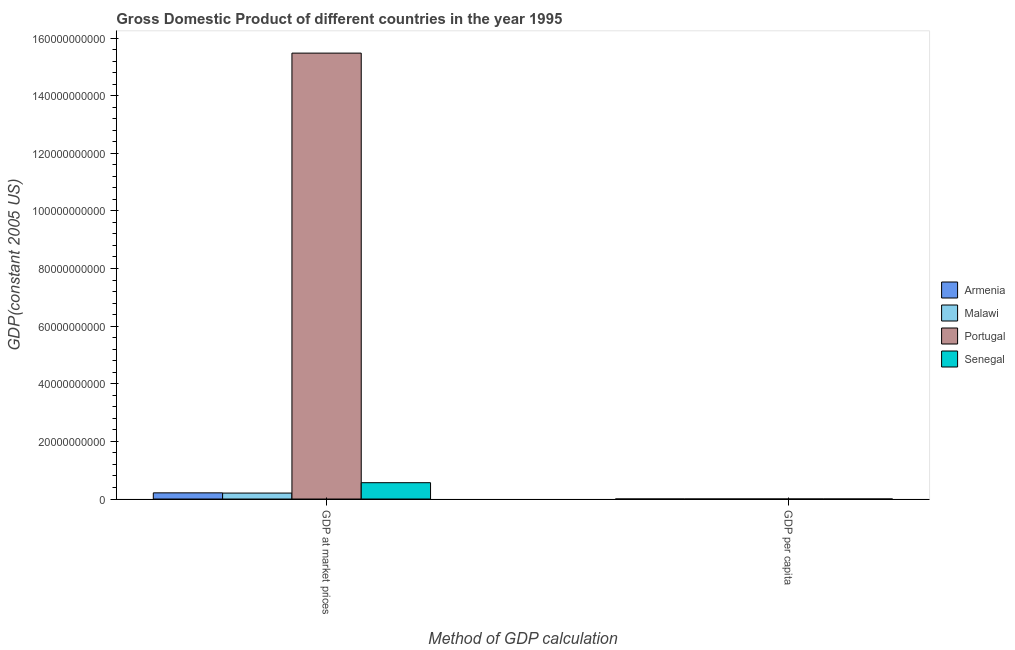How many different coloured bars are there?
Ensure brevity in your answer.  4. How many groups of bars are there?
Provide a succinct answer. 2. Are the number of bars per tick equal to the number of legend labels?
Keep it short and to the point. Yes. Are the number of bars on each tick of the X-axis equal?
Make the answer very short. Yes. How many bars are there on the 1st tick from the left?
Provide a succinct answer. 4. How many bars are there on the 2nd tick from the right?
Keep it short and to the point. 4. What is the label of the 1st group of bars from the left?
Keep it short and to the point. GDP at market prices. What is the gdp per capita in Armenia?
Your response must be concise. 665.72. Across all countries, what is the maximum gdp at market prices?
Provide a short and direct response. 1.55e+11. Across all countries, what is the minimum gdp per capita?
Your answer should be very brief. 210.62. In which country was the gdp at market prices minimum?
Your response must be concise. Malawi. What is the total gdp per capita in the graph?
Provide a succinct answer. 1.70e+04. What is the difference between the gdp at market prices in Armenia and that in Malawi?
Offer a terse response. 7.68e+07. What is the difference between the gdp at market prices in Portugal and the gdp per capita in Armenia?
Keep it short and to the point. 1.55e+11. What is the average gdp per capita per country?
Provide a short and direct response. 4240.57. What is the difference between the gdp per capita and gdp at market prices in Armenia?
Offer a very short reply. -2.15e+09. What is the ratio of the gdp per capita in Armenia to that in Portugal?
Provide a succinct answer. 0.04. Is the gdp per capita in Armenia less than that in Malawi?
Offer a terse response. No. What does the 3rd bar from the left in GDP at market prices represents?
Keep it short and to the point. Portugal. What does the 4th bar from the right in GDP at market prices represents?
Provide a short and direct response. Armenia. What is the difference between two consecutive major ticks on the Y-axis?
Your answer should be very brief. 2.00e+1. Are the values on the major ticks of Y-axis written in scientific E-notation?
Keep it short and to the point. No. Where does the legend appear in the graph?
Ensure brevity in your answer.  Center right. How many legend labels are there?
Your answer should be very brief. 4. What is the title of the graph?
Your answer should be compact. Gross Domestic Product of different countries in the year 1995. What is the label or title of the X-axis?
Provide a short and direct response. Method of GDP calculation. What is the label or title of the Y-axis?
Offer a very short reply. GDP(constant 2005 US). What is the GDP(constant 2005 US) of Armenia in GDP at market prices?
Make the answer very short. 2.15e+09. What is the GDP(constant 2005 US) of Malawi in GDP at market prices?
Make the answer very short. 2.07e+09. What is the GDP(constant 2005 US) in Portugal in GDP at market prices?
Ensure brevity in your answer.  1.55e+11. What is the GDP(constant 2005 US) in Senegal in GDP at market prices?
Offer a terse response. 5.67e+09. What is the GDP(constant 2005 US) of Armenia in GDP per capita?
Make the answer very short. 665.72. What is the GDP(constant 2005 US) in Malawi in GDP per capita?
Your answer should be very brief. 210.62. What is the GDP(constant 2005 US) of Portugal in GDP per capita?
Provide a short and direct response. 1.54e+04. What is the GDP(constant 2005 US) in Senegal in GDP per capita?
Offer a terse response. 651.02. Across all Method of GDP calculation, what is the maximum GDP(constant 2005 US) of Armenia?
Give a very brief answer. 2.15e+09. Across all Method of GDP calculation, what is the maximum GDP(constant 2005 US) in Malawi?
Keep it short and to the point. 2.07e+09. Across all Method of GDP calculation, what is the maximum GDP(constant 2005 US) in Portugal?
Your answer should be very brief. 1.55e+11. Across all Method of GDP calculation, what is the maximum GDP(constant 2005 US) of Senegal?
Offer a terse response. 5.67e+09. Across all Method of GDP calculation, what is the minimum GDP(constant 2005 US) in Armenia?
Your answer should be compact. 665.72. Across all Method of GDP calculation, what is the minimum GDP(constant 2005 US) of Malawi?
Give a very brief answer. 210.62. Across all Method of GDP calculation, what is the minimum GDP(constant 2005 US) in Portugal?
Give a very brief answer. 1.54e+04. Across all Method of GDP calculation, what is the minimum GDP(constant 2005 US) of Senegal?
Provide a succinct answer. 651.02. What is the total GDP(constant 2005 US) of Armenia in the graph?
Ensure brevity in your answer.  2.15e+09. What is the total GDP(constant 2005 US) of Malawi in the graph?
Keep it short and to the point. 2.07e+09. What is the total GDP(constant 2005 US) of Portugal in the graph?
Your answer should be compact. 1.55e+11. What is the total GDP(constant 2005 US) in Senegal in the graph?
Provide a succinct answer. 5.67e+09. What is the difference between the GDP(constant 2005 US) of Armenia in GDP at market prices and that in GDP per capita?
Provide a short and direct response. 2.15e+09. What is the difference between the GDP(constant 2005 US) of Malawi in GDP at market prices and that in GDP per capita?
Give a very brief answer. 2.07e+09. What is the difference between the GDP(constant 2005 US) in Portugal in GDP at market prices and that in GDP per capita?
Keep it short and to the point. 1.55e+11. What is the difference between the GDP(constant 2005 US) in Senegal in GDP at market prices and that in GDP per capita?
Provide a succinct answer. 5.67e+09. What is the difference between the GDP(constant 2005 US) of Armenia in GDP at market prices and the GDP(constant 2005 US) of Malawi in GDP per capita?
Keep it short and to the point. 2.15e+09. What is the difference between the GDP(constant 2005 US) in Armenia in GDP at market prices and the GDP(constant 2005 US) in Portugal in GDP per capita?
Your answer should be compact. 2.15e+09. What is the difference between the GDP(constant 2005 US) in Armenia in GDP at market prices and the GDP(constant 2005 US) in Senegal in GDP per capita?
Your answer should be compact. 2.15e+09. What is the difference between the GDP(constant 2005 US) in Malawi in GDP at market prices and the GDP(constant 2005 US) in Portugal in GDP per capita?
Provide a short and direct response. 2.07e+09. What is the difference between the GDP(constant 2005 US) in Malawi in GDP at market prices and the GDP(constant 2005 US) in Senegal in GDP per capita?
Give a very brief answer. 2.07e+09. What is the difference between the GDP(constant 2005 US) of Portugal in GDP at market prices and the GDP(constant 2005 US) of Senegal in GDP per capita?
Offer a very short reply. 1.55e+11. What is the average GDP(constant 2005 US) of Armenia per Method of GDP calculation?
Ensure brevity in your answer.  1.07e+09. What is the average GDP(constant 2005 US) in Malawi per Method of GDP calculation?
Provide a succinct answer. 1.03e+09. What is the average GDP(constant 2005 US) of Portugal per Method of GDP calculation?
Provide a short and direct response. 7.74e+1. What is the average GDP(constant 2005 US) of Senegal per Method of GDP calculation?
Offer a terse response. 2.84e+09. What is the difference between the GDP(constant 2005 US) in Armenia and GDP(constant 2005 US) in Malawi in GDP at market prices?
Provide a succinct answer. 7.68e+07. What is the difference between the GDP(constant 2005 US) of Armenia and GDP(constant 2005 US) of Portugal in GDP at market prices?
Your response must be concise. -1.53e+11. What is the difference between the GDP(constant 2005 US) of Armenia and GDP(constant 2005 US) of Senegal in GDP at market prices?
Your answer should be very brief. -3.53e+09. What is the difference between the GDP(constant 2005 US) of Malawi and GDP(constant 2005 US) of Portugal in GDP at market prices?
Your answer should be compact. -1.53e+11. What is the difference between the GDP(constant 2005 US) of Malawi and GDP(constant 2005 US) of Senegal in GDP at market prices?
Your response must be concise. -3.60e+09. What is the difference between the GDP(constant 2005 US) in Portugal and GDP(constant 2005 US) in Senegal in GDP at market prices?
Your response must be concise. 1.49e+11. What is the difference between the GDP(constant 2005 US) in Armenia and GDP(constant 2005 US) in Malawi in GDP per capita?
Provide a short and direct response. 455.1. What is the difference between the GDP(constant 2005 US) of Armenia and GDP(constant 2005 US) of Portugal in GDP per capita?
Make the answer very short. -1.48e+04. What is the difference between the GDP(constant 2005 US) in Armenia and GDP(constant 2005 US) in Senegal in GDP per capita?
Ensure brevity in your answer.  14.7. What is the difference between the GDP(constant 2005 US) of Malawi and GDP(constant 2005 US) of Portugal in GDP per capita?
Your response must be concise. -1.52e+04. What is the difference between the GDP(constant 2005 US) in Malawi and GDP(constant 2005 US) in Senegal in GDP per capita?
Provide a succinct answer. -440.4. What is the difference between the GDP(constant 2005 US) of Portugal and GDP(constant 2005 US) of Senegal in GDP per capita?
Ensure brevity in your answer.  1.48e+04. What is the ratio of the GDP(constant 2005 US) of Armenia in GDP at market prices to that in GDP per capita?
Make the answer very short. 3.22e+06. What is the ratio of the GDP(constant 2005 US) in Malawi in GDP at market prices to that in GDP per capita?
Your answer should be very brief. 9.82e+06. What is the ratio of the GDP(constant 2005 US) in Portugal in GDP at market prices to that in GDP per capita?
Provide a short and direct response. 1.00e+07. What is the ratio of the GDP(constant 2005 US) in Senegal in GDP at market prices to that in GDP per capita?
Provide a succinct answer. 8.71e+06. What is the difference between the highest and the second highest GDP(constant 2005 US) in Armenia?
Ensure brevity in your answer.  2.15e+09. What is the difference between the highest and the second highest GDP(constant 2005 US) in Malawi?
Keep it short and to the point. 2.07e+09. What is the difference between the highest and the second highest GDP(constant 2005 US) of Portugal?
Your answer should be compact. 1.55e+11. What is the difference between the highest and the second highest GDP(constant 2005 US) of Senegal?
Give a very brief answer. 5.67e+09. What is the difference between the highest and the lowest GDP(constant 2005 US) in Armenia?
Provide a succinct answer. 2.15e+09. What is the difference between the highest and the lowest GDP(constant 2005 US) in Malawi?
Offer a terse response. 2.07e+09. What is the difference between the highest and the lowest GDP(constant 2005 US) of Portugal?
Your answer should be very brief. 1.55e+11. What is the difference between the highest and the lowest GDP(constant 2005 US) in Senegal?
Your response must be concise. 5.67e+09. 